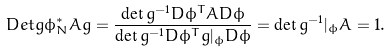<formula> <loc_0><loc_0><loc_500><loc_500>\ D e t g { \phi _ { N } ^ { * } A } { g } = \frac { \det { g ^ { - 1 } D \phi ^ { T } A D \phi } } { \det { g ^ { - 1 } D \phi ^ { T } g | _ { \phi } D \phi } } = \det { g ^ { - 1 } | _ { \phi } A } = 1 .</formula> 